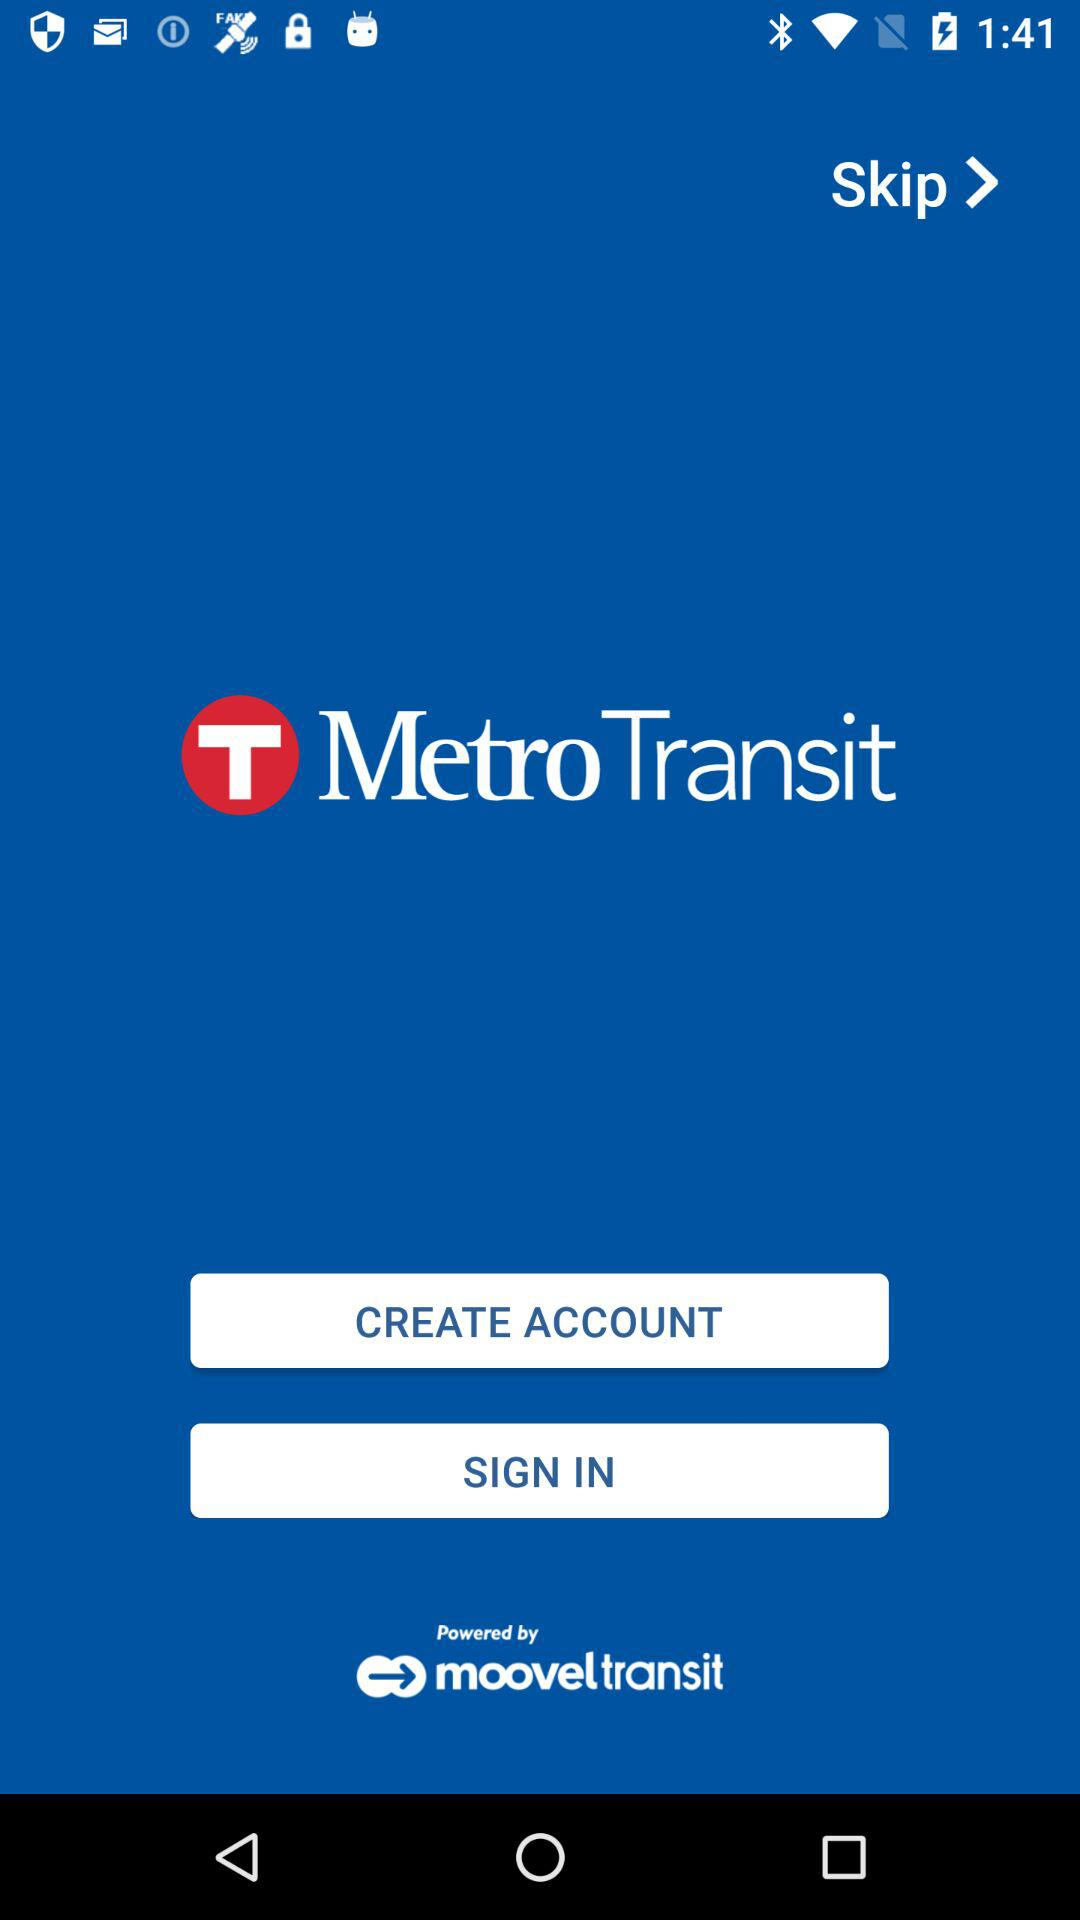The application is powered by whom? The application is powered by mooveltransit. 